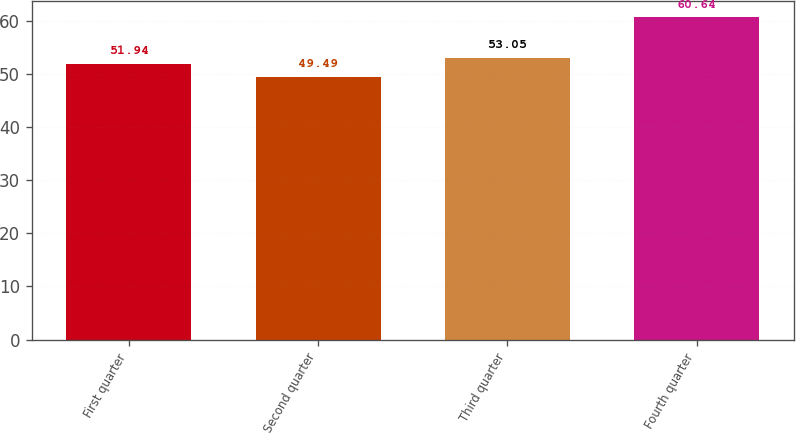Convert chart. <chart><loc_0><loc_0><loc_500><loc_500><bar_chart><fcel>First quarter<fcel>Second quarter<fcel>Third quarter<fcel>Fourth quarter<nl><fcel>51.94<fcel>49.49<fcel>53.05<fcel>60.64<nl></chart> 